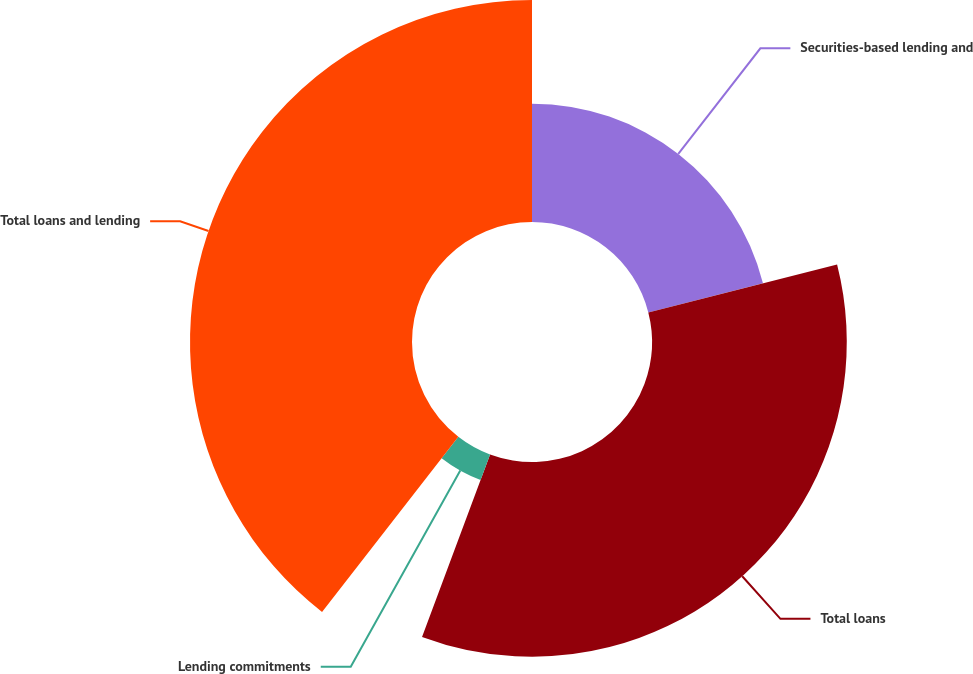<chart> <loc_0><loc_0><loc_500><loc_500><pie_chart><fcel>Securities-based lending and<fcel>Total loans<fcel>Lending commitments<fcel>Total loans and lending<nl><fcel>21.04%<fcel>34.64%<fcel>4.84%<fcel>39.48%<nl></chart> 